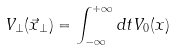<formula> <loc_0><loc_0><loc_500><loc_500>V _ { \perp } ( \vec { x } _ { \perp } ) = \int _ { - \infty } ^ { + \infty } d t V _ { 0 } ( x )</formula> 